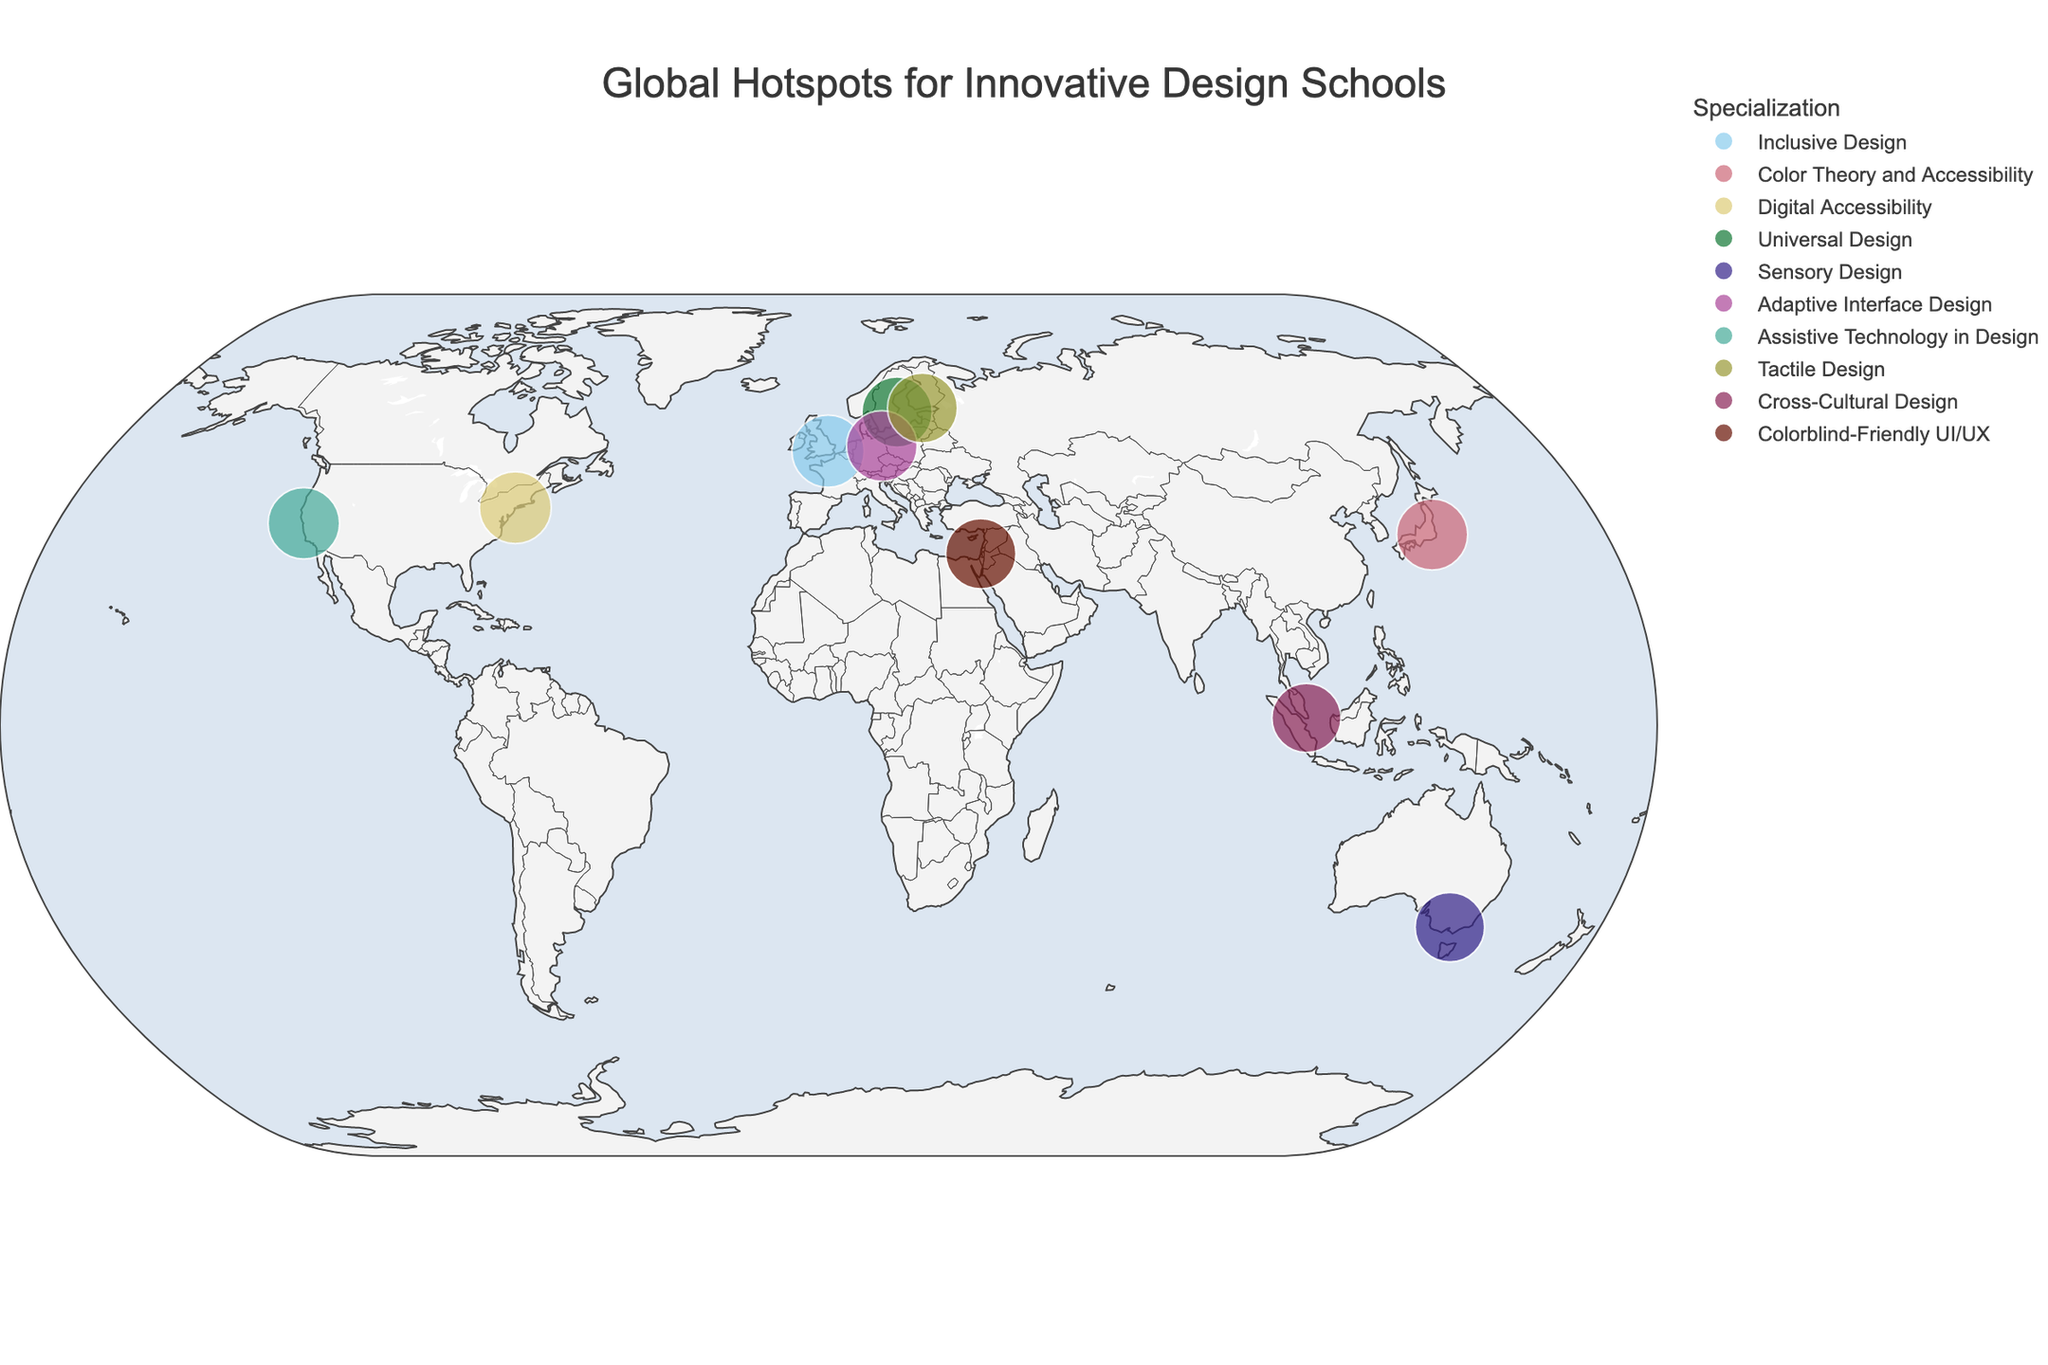Where is the school that specializes in Sensory Design located? Look for the location marked with the name "RMIT University" and note its location.
Answer: Melbourne Which school has the highest Innovation Score? Check the size of the markers (since size denotes Innovation Score) and find the largest one. The largest marker corresponds to the school with the highest Innovation Score.
Answer: Royal College of Art Which color is used to represent Digital Accessibility? Identify the marker that corresponds to the specialization "Digital Accessibility" and note its color.
Answer: Depends on color palette used; in this case, a specific color from the "Safe" qualitative color scale How many schools are located in Europe? Identify the schools located in Europe by their city names: London, Stockholm, Berlin, and Helsinki.
Answer: 4 What is the average Innovation Score for schools located in Asia? Look at the Innovation Scores for schools in Tokyo, Singapore, and Tel Aviv. Calculate the average by summing these scores and dividing by the number of schools. (8.9 + 8.4 + 8.7) / 3 = 8.67
Answer: 8.67 Which school specializes in Universal Design and what is its Innovation Score? Identify the marker corresponding to "Universal Design" and note the name of the school and its Innovation Score.
Answer: Konstfack, 8.7 Is there any school in the Southern Hemisphere, and if so, which one? Look for markers located below the equator. Note the name of the school.
Answer: RMIT University What is the difference in Innovation Score between the highest and lowest scoring schools? Identify the highest and lowest Innovation Scores from the markers. The difference is calculated as 9.2 (highest) - 8.4 (lowest) = 0.8
Answer: 0.8 Which school specializes in Colorblind-Friendly UI/UX Design, and where is it located? Look for the marker corresponding to the specialization "Colorblind-Friendly UI/UX" and note the school and location.
Answer: Shenkar College, Tel Aviv Compare the Innovation Scores of Parsons School of Design and California College of the Arts. Which one is higher? Identify the markers for Parsons School of Design and California College of the Arts and compare their Innovation Scores.
Answer: Parsons School of Design has a higher score 